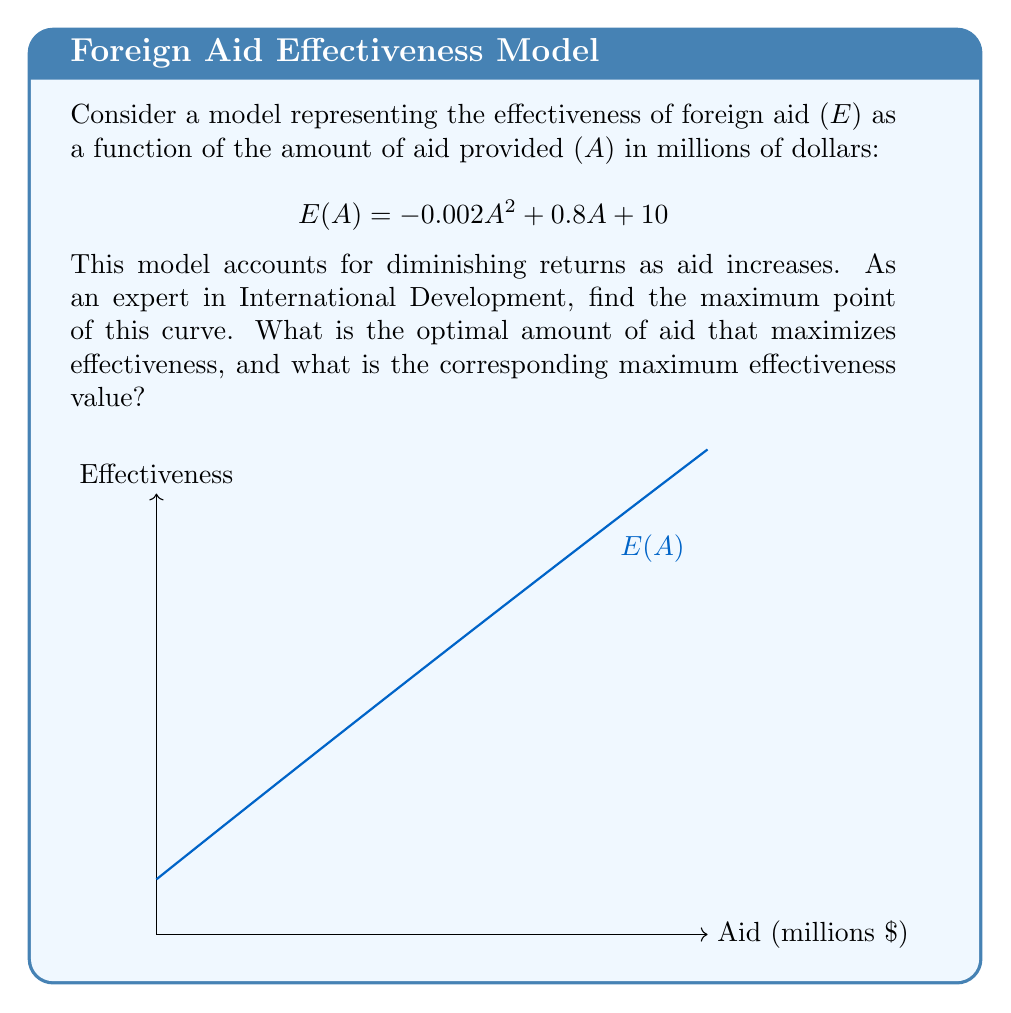What is the answer to this math problem? To find the maximum point of the curve, we need to follow these steps:

1) First, we find the derivative of the function:
   $$ E'(A) = \frac{d}{dA}(-0.002A^2 + 0.8A + 10) = -0.004A + 0.8 $$

2) Set the derivative equal to zero to find the critical point:
   $$ -0.004A + 0.8 = 0 $$
   $$ -0.004A = -0.8 $$
   $$ A = 200 $$

3) To confirm this is a maximum, we can check the second derivative:
   $$ E''(A) = -0.004 $$
   Since this is negative, the critical point is indeed a maximum.

4) To find the maximum effectiveness, we plug A = 200 into the original function:
   $$ E(200) = -0.002(200)^2 + 0.8(200) + 10 $$
   $$ = -80 + 160 + 10 = 90 $$

Therefore, the optimal amount of aid is 200 million dollars, resulting in a maximum effectiveness of 90 units.
Answer: Optimal aid: $200 million; Maximum effectiveness: 90 units 